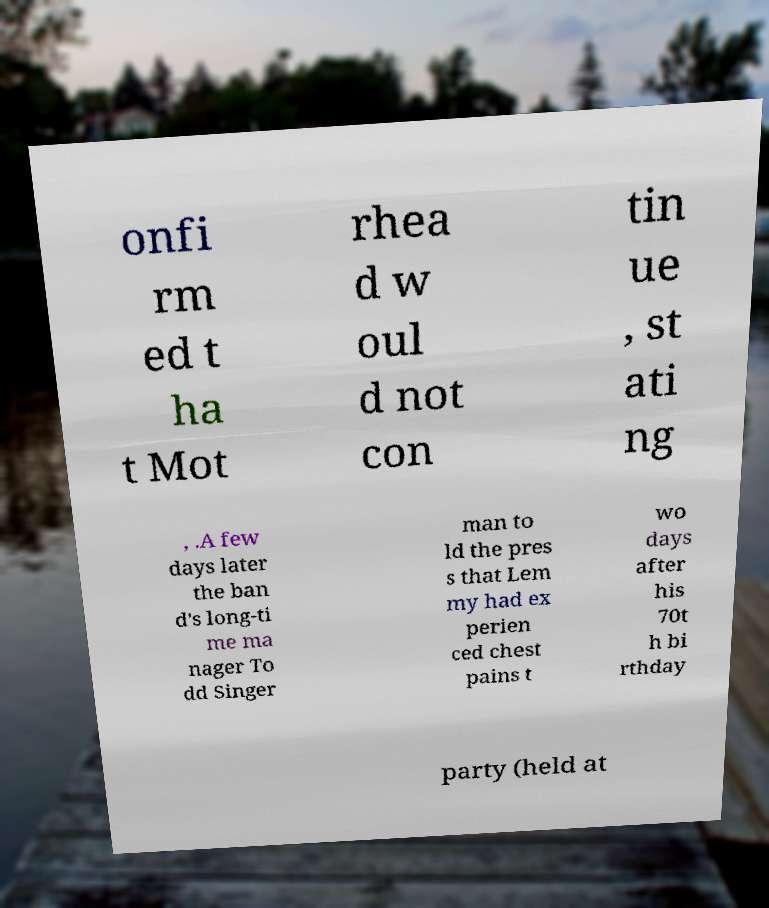I need the written content from this picture converted into text. Can you do that? onfi rm ed t ha t Mot rhea d w oul d not con tin ue , st ati ng , .A few days later the ban d's long-ti me ma nager To dd Singer man to ld the pres s that Lem my had ex perien ced chest pains t wo days after his 70t h bi rthday party (held at 